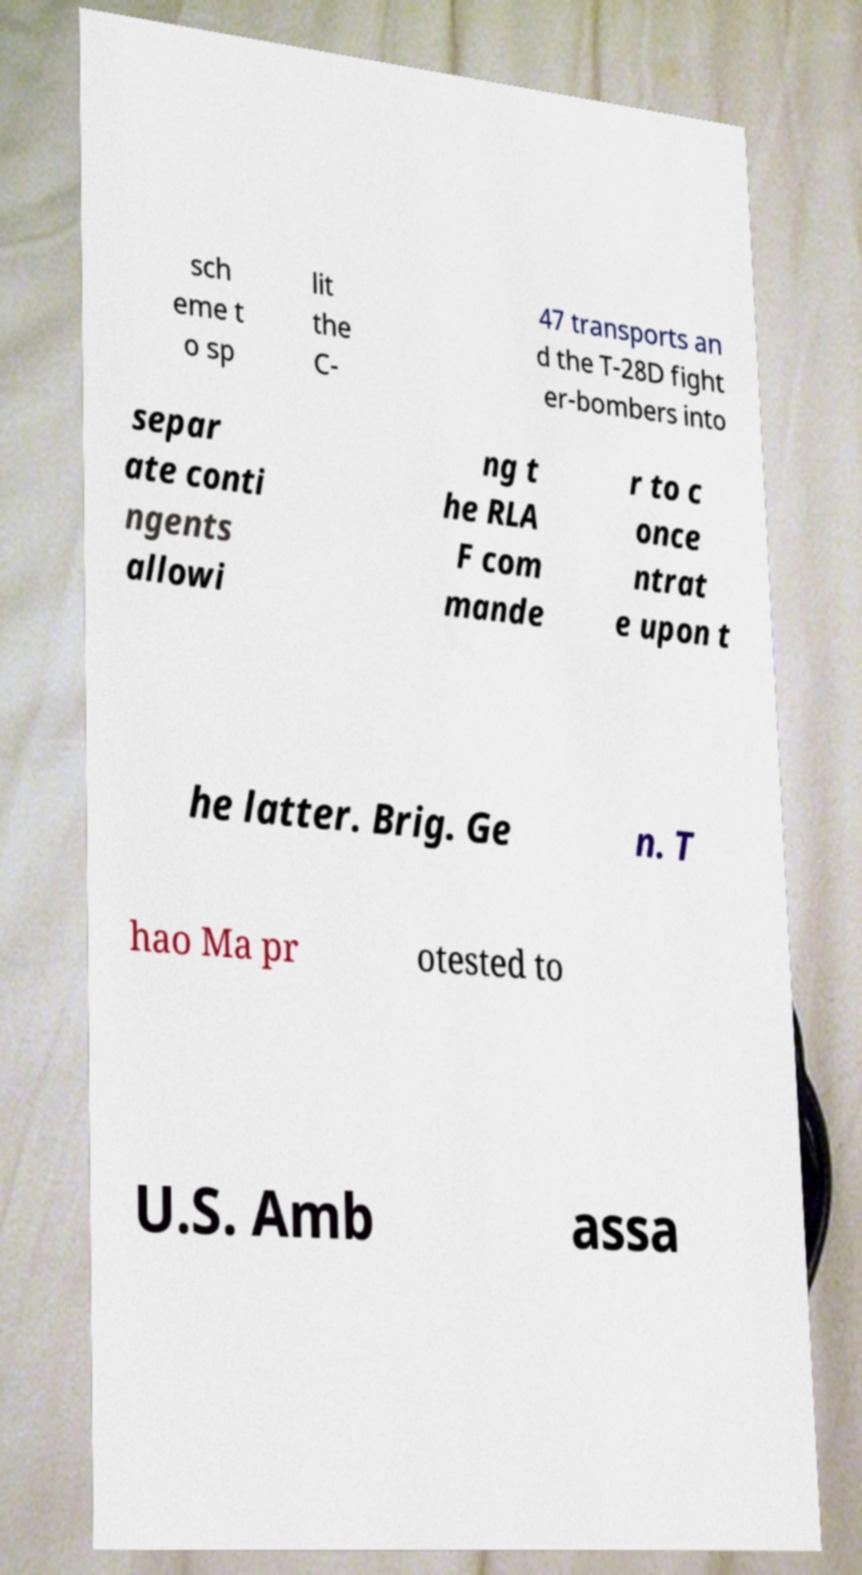Could you assist in decoding the text presented in this image and type it out clearly? sch eme t o sp lit the C- 47 transports an d the T-28D fight er-bombers into separ ate conti ngents allowi ng t he RLA F com mande r to c once ntrat e upon t he latter. Brig. Ge n. T hao Ma pr otested to U.S. Amb assa 